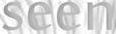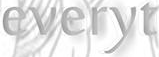Read the text content from these images in order, separated by a semicolon. seen; everyt 